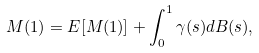Convert formula to latex. <formula><loc_0><loc_0><loc_500><loc_500>M ( 1 ) = E [ M ( 1 ) ] + \int _ { 0 } ^ { 1 } \gamma ( s ) d B ( s ) ,</formula> 